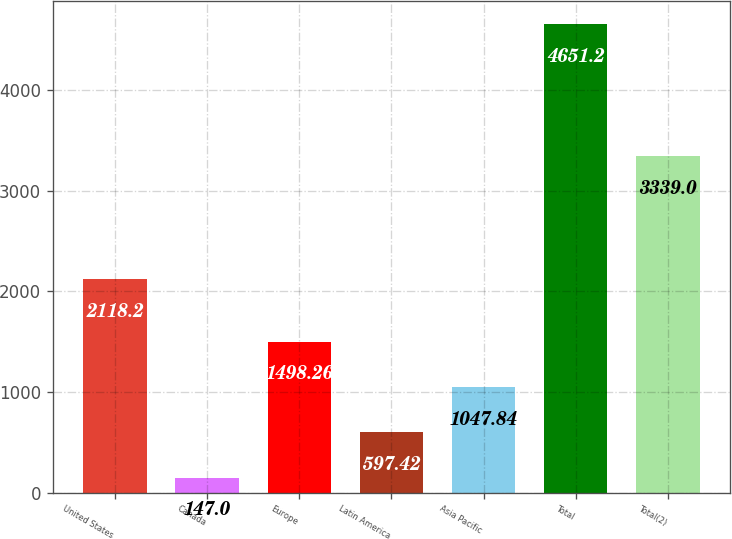Convert chart. <chart><loc_0><loc_0><loc_500><loc_500><bar_chart><fcel>United States<fcel>Canada<fcel>Europe<fcel>Latin America<fcel>Asia Pacific<fcel>Total<fcel>Total(2)<nl><fcel>2118.2<fcel>147<fcel>1498.26<fcel>597.42<fcel>1047.84<fcel>4651.2<fcel>3339<nl></chart> 